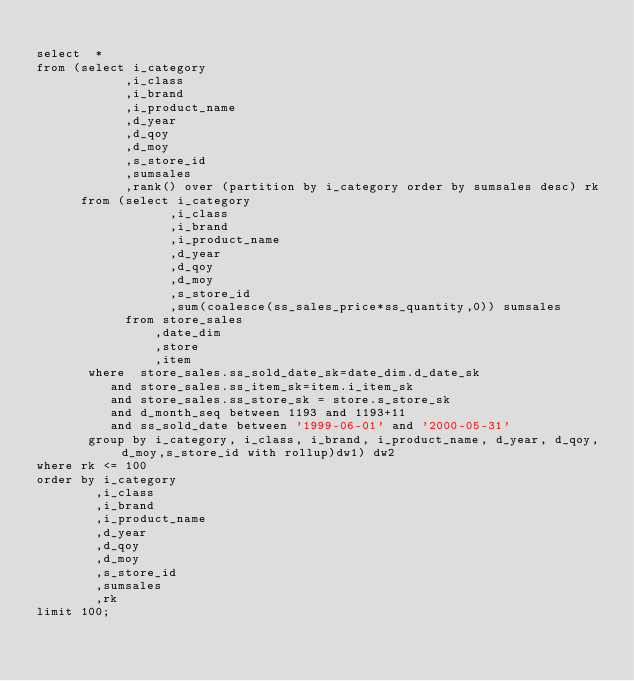Convert code to text. <code><loc_0><loc_0><loc_500><loc_500><_SQL_>
select  *
from (select i_category
            ,i_class
            ,i_brand
            ,i_product_name
            ,d_year
            ,d_qoy
            ,d_moy
            ,s_store_id
            ,sumsales
            ,rank() over (partition by i_category order by sumsales desc) rk
      from (select i_category
                  ,i_class
                  ,i_brand
                  ,i_product_name
                  ,d_year
                  ,d_qoy
                  ,d_moy
                  ,s_store_id
                  ,sum(coalesce(ss_sales_price*ss_quantity,0)) sumsales
            from store_sales
                ,date_dim
                ,store
                ,item
       where  store_sales.ss_sold_date_sk=date_dim.d_date_sk
          and store_sales.ss_item_sk=item.i_item_sk
          and store_sales.ss_store_sk = store.s_store_sk
          and d_month_seq between 1193 and 1193+11
          and ss_sold_date between '1999-06-01' and '2000-05-31'
       group by i_category, i_class, i_brand, i_product_name, d_year, d_qoy, d_moy,s_store_id with rollup)dw1) dw2
where rk <= 100
order by i_category
        ,i_class
        ,i_brand
        ,i_product_name
        ,d_year
        ,d_qoy
        ,d_moy
        ,s_store_id
        ,sumsales
        ,rk
limit 100;


</code> 